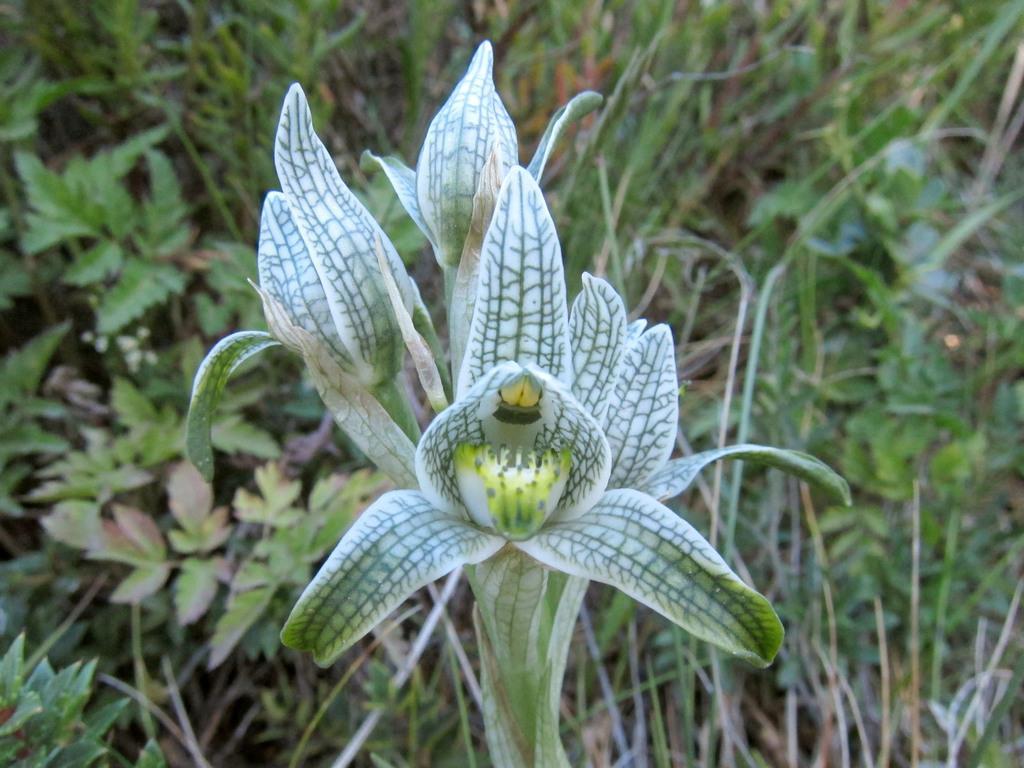In one or two sentences, can you explain what this image depicts? In this image, we can see a wild flower and in the background there are is green grass and we can see some green color leaves. 